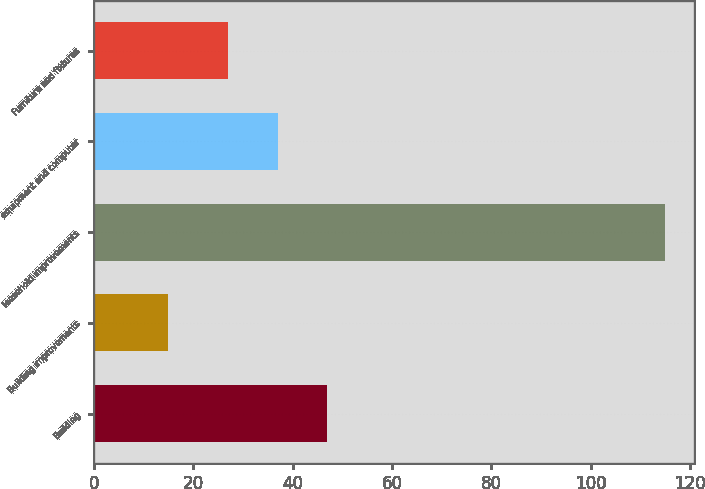<chart> <loc_0><loc_0><loc_500><loc_500><bar_chart><fcel>Building<fcel>Building improvements<fcel>leasehold improvements<fcel>equipment and computer<fcel>Furniture and fixtures<nl><fcel>47<fcel>15<fcel>115<fcel>37<fcel>27<nl></chart> 